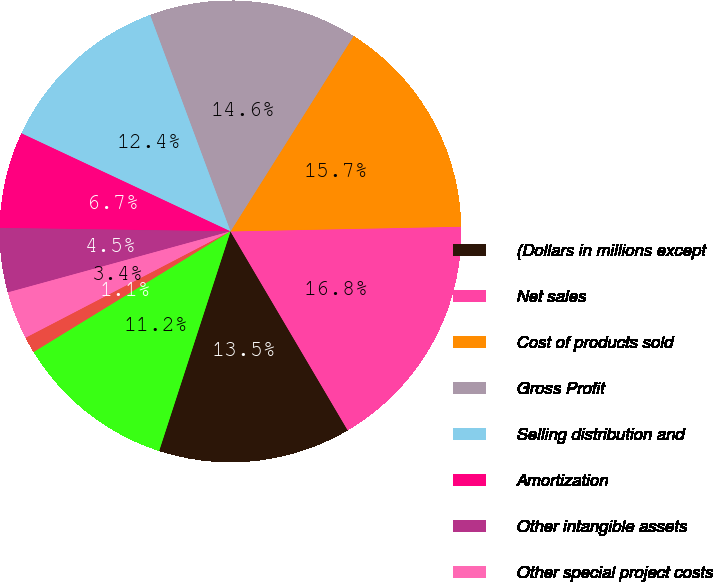Convert chart. <chart><loc_0><loc_0><loc_500><loc_500><pie_chart><fcel>(Dollars in millions except<fcel>Net sales<fcel>Cost of products sold<fcel>Gross Profit<fcel>Selling distribution and<fcel>Amortization<fcel>Other intangible assets<fcel>Other special project costs<fcel>Other operating expense<fcel>Operating Income<nl><fcel>13.48%<fcel>16.85%<fcel>15.73%<fcel>14.61%<fcel>12.36%<fcel>6.74%<fcel>4.5%<fcel>3.37%<fcel>1.13%<fcel>11.24%<nl></chart> 